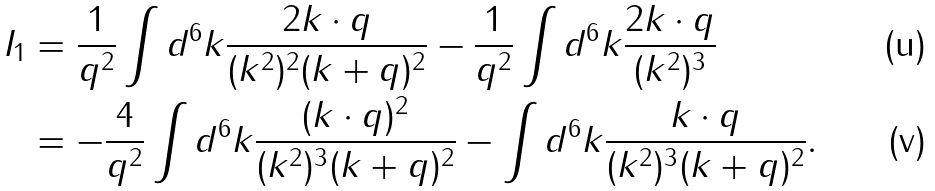Convert formula to latex. <formula><loc_0><loc_0><loc_500><loc_500>I _ { 1 } & = \frac { 1 } { q ^ { 2 } } \int d ^ { 6 } k \frac { 2 k \cdot q } { ( k ^ { 2 } ) ^ { 2 } ( k + q ) ^ { 2 } } - \frac { 1 } { q ^ { 2 } } \int d ^ { 6 } k \frac { 2 k \cdot q } { ( k ^ { 2 } ) ^ { 3 } } \\ & = - \frac { 4 } { q ^ { 2 } } \int d ^ { 6 } k \frac { ( k \cdot q ) ^ { 2 } } { ( k ^ { 2 } ) ^ { 3 } ( k + q ) ^ { 2 } } - \int d ^ { 6 } k \frac { k \cdot q } { ( k ^ { 2 } ) ^ { 3 } ( k + q ) ^ { 2 } } .</formula> 